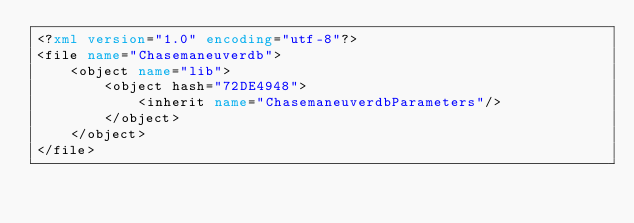<code> <loc_0><loc_0><loc_500><loc_500><_XML_><?xml version="1.0" encoding="utf-8"?>
<file name="Chasemaneuverdb">
	<object name="lib">
		<object hash="72DE4948">
			<inherit name="ChasemaneuverdbParameters"/>
		</object>
	</object>
</file>
</code> 